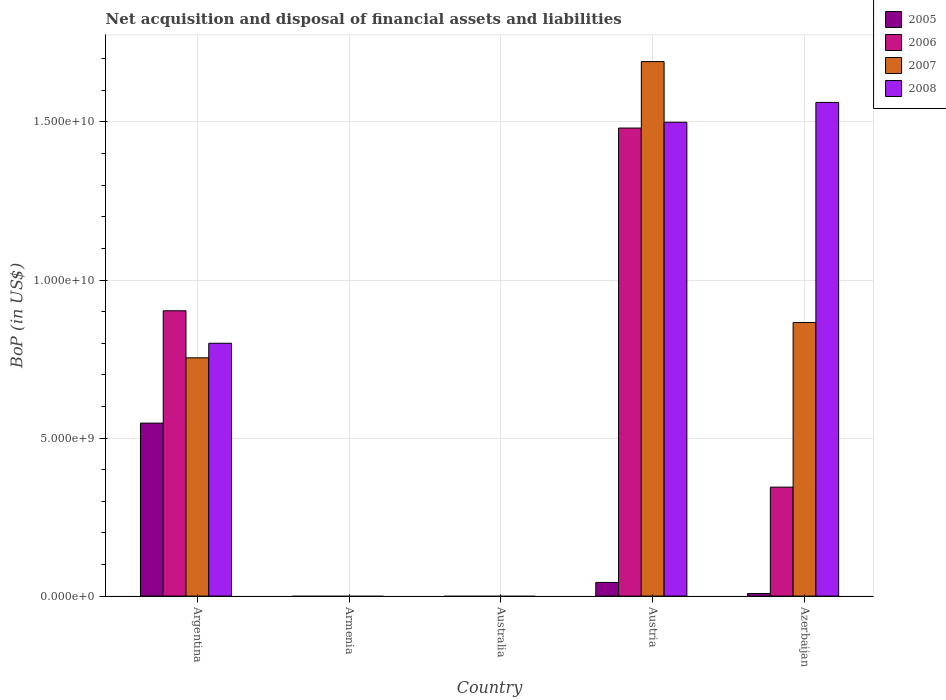How many different coloured bars are there?
Offer a very short reply. 4. How many bars are there on the 2nd tick from the right?
Your response must be concise. 4. What is the label of the 5th group of bars from the left?
Provide a succinct answer. Azerbaijan. In how many cases, is the number of bars for a given country not equal to the number of legend labels?
Provide a short and direct response. 2. What is the Balance of Payments in 2006 in Azerbaijan?
Provide a short and direct response. 3.45e+09. Across all countries, what is the maximum Balance of Payments in 2007?
Your answer should be very brief. 1.69e+1. Across all countries, what is the minimum Balance of Payments in 2007?
Provide a short and direct response. 0. In which country was the Balance of Payments in 2008 maximum?
Provide a succinct answer. Azerbaijan. What is the total Balance of Payments in 2007 in the graph?
Give a very brief answer. 3.31e+1. What is the difference between the Balance of Payments in 2007 in Argentina and that in Azerbaijan?
Provide a short and direct response. -1.12e+09. What is the difference between the Balance of Payments in 2005 in Argentina and the Balance of Payments in 2007 in Azerbaijan?
Provide a succinct answer. -3.18e+09. What is the average Balance of Payments in 2008 per country?
Offer a very short reply. 7.72e+09. What is the difference between the Balance of Payments of/in 2007 and Balance of Payments of/in 2006 in Azerbaijan?
Give a very brief answer. 5.21e+09. In how many countries, is the Balance of Payments in 2006 greater than 3000000000 US$?
Provide a succinct answer. 3. What is the ratio of the Balance of Payments in 2007 in Argentina to that in Austria?
Your response must be concise. 0.45. Is the Balance of Payments in 2006 in Argentina less than that in Austria?
Provide a succinct answer. Yes. What is the difference between the highest and the second highest Balance of Payments in 2008?
Offer a very short reply. 7.62e+09. What is the difference between the highest and the lowest Balance of Payments in 2008?
Your answer should be compact. 1.56e+1. In how many countries, is the Balance of Payments in 2006 greater than the average Balance of Payments in 2006 taken over all countries?
Your response must be concise. 2. How many countries are there in the graph?
Your answer should be compact. 5. What is the difference between two consecutive major ticks on the Y-axis?
Provide a short and direct response. 5.00e+09. Are the values on the major ticks of Y-axis written in scientific E-notation?
Provide a short and direct response. Yes. Does the graph contain any zero values?
Provide a succinct answer. Yes. Does the graph contain grids?
Keep it short and to the point. Yes. Where does the legend appear in the graph?
Offer a terse response. Top right. What is the title of the graph?
Your answer should be very brief. Net acquisition and disposal of financial assets and liabilities. Does "1983" appear as one of the legend labels in the graph?
Keep it short and to the point. No. What is the label or title of the X-axis?
Provide a succinct answer. Country. What is the label or title of the Y-axis?
Offer a terse response. BoP (in US$). What is the BoP (in US$) of 2005 in Argentina?
Ensure brevity in your answer.  5.47e+09. What is the BoP (in US$) in 2006 in Argentina?
Keep it short and to the point. 9.03e+09. What is the BoP (in US$) of 2007 in Argentina?
Your answer should be compact. 7.54e+09. What is the BoP (in US$) of 2008 in Argentina?
Your answer should be very brief. 8.00e+09. What is the BoP (in US$) in 2006 in Armenia?
Your answer should be compact. 0. What is the BoP (in US$) in 2008 in Armenia?
Your answer should be very brief. 0. What is the BoP (in US$) in 2006 in Australia?
Provide a short and direct response. 0. What is the BoP (in US$) in 2007 in Australia?
Offer a very short reply. 0. What is the BoP (in US$) of 2008 in Australia?
Provide a short and direct response. 0. What is the BoP (in US$) in 2005 in Austria?
Your answer should be very brief. 4.32e+08. What is the BoP (in US$) in 2006 in Austria?
Make the answer very short. 1.48e+1. What is the BoP (in US$) of 2007 in Austria?
Give a very brief answer. 1.69e+1. What is the BoP (in US$) in 2008 in Austria?
Offer a terse response. 1.50e+1. What is the BoP (in US$) in 2005 in Azerbaijan?
Provide a short and direct response. 8.26e+07. What is the BoP (in US$) in 2006 in Azerbaijan?
Your answer should be very brief. 3.45e+09. What is the BoP (in US$) in 2007 in Azerbaijan?
Provide a succinct answer. 8.66e+09. What is the BoP (in US$) of 2008 in Azerbaijan?
Your answer should be compact. 1.56e+1. Across all countries, what is the maximum BoP (in US$) in 2005?
Provide a succinct answer. 5.47e+09. Across all countries, what is the maximum BoP (in US$) in 2006?
Your response must be concise. 1.48e+1. Across all countries, what is the maximum BoP (in US$) of 2007?
Your response must be concise. 1.69e+1. Across all countries, what is the maximum BoP (in US$) in 2008?
Offer a terse response. 1.56e+1. Across all countries, what is the minimum BoP (in US$) in 2005?
Provide a short and direct response. 0. Across all countries, what is the minimum BoP (in US$) in 2006?
Your answer should be very brief. 0. What is the total BoP (in US$) of 2005 in the graph?
Your response must be concise. 5.99e+09. What is the total BoP (in US$) in 2006 in the graph?
Your response must be concise. 2.73e+1. What is the total BoP (in US$) of 2007 in the graph?
Your response must be concise. 3.31e+1. What is the total BoP (in US$) in 2008 in the graph?
Your answer should be very brief. 3.86e+1. What is the difference between the BoP (in US$) in 2005 in Argentina and that in Austria?
Give a very brief answer. 5.04e+09. What is the difference between the BoP (in US$) in 2006 in Argentina and that in Austria?
Your answer should be very brief. -5.78e+09. What is the difference between the BoP (in US$) in 2007 in Argentina and that in Austria?
Ensure brevity in your answer.  -9.37e+09. What is the difference between the BoP (in US$) in 2008 in Argentina and that in Austria?
Provide a short and direct response. -6.99e+09. What is the difference between the BoP (in US$) of 2005 in Argentina and that in Azerbaijan?
Keep it short and to the point. 5.39e+09. What is the difference between the BoP (in US$) in 2006 in Argentina and that in Azerbaijan?
Keep it short and to the point. 5.58e+09. What is the difference between the BoP (in US$) in 2007 in Argentina and that in Azerbaijan?
Offer a terse response. -1.12e+09. What is the difference between the BoP (in US$) in 2008 in Argentina and that in Azerbaijan?
Offer a very short reply. -7.62e+09. What is the difference between the BoP (in US$) in 2005 in Austria and that in Azerbaijan?
Offer a terse response. 3.50e+08. What is the difference between the BoP (in US$) in 2006 in Austria and that in Azerbaijan?
Offer a terse response. 1.14e+1. What is the difference between the BoP (in US$) of 2007 in Austria and that in Azerbaijan?
Offer a terse response. 8.26e+09. What is the difference between the BoP (in US$) in 2008 in Austria and that in Azerbaijan?
Provide a succinct answer. -6.27e+08. What is the difference between the BoP (in US$) of 2005 in Argentina and the BoP (in US$) of 2006 in Austria?
Provide a short and direct response. -9.33e+09. What is the difference between the BoP (in US$) of 2005 in Argentina and the BoP (in US$) of 2007 in Austria?
Make the answer very short. -1.14e+1. What is the difference between the BoP (in US$) in 2005 in Argentina and the BoP (in US$) in 2008 in Austria?
Offer a terse response. -9.52e+09. What is the difference between the BoP (in US$) in 2006 in Argentina and the BoP (in US$) in 2007 in Austria?
Your answer should be compact. -7.88e+09. What is the difference between the BoP (in US$) of 2006 in Argentina and the BoP (in US$) of 2008 in Austria?
Your answer should be very brief. -5.96e+09. What is the difference between the BoP (in US$) of 2007 in Argentina and the BoP (in US$) of 2008 in Austria?
Provide a short and direct response. -7.45e+09. What is the difference between the BoP (in US$) of 2005 in Argentina and the BoP (in US$) of 2006 in Azerbaijan?
Offer a very short reply. 2.03e+09. What is the difference between the BoP (in US$) in 2005 in Argentina and the BoP (in US$) in 2007 in Azerbaijan?
Provide a short and direct response. -3.18e+09. What is the difference between the BoP (in US$) in 2005 in Argentina and the BoP (in US$) in 2008 in Azerbaijan?
Your answer should be very brief. -1.01e+1. What is the difference between the BoP (in US$) of 2006 in Argentina and the BoP (in US$) of 2007 in Azerbaijan?
Offer a terse response. 3.72e+08. What is the difference between the BoP (in US$) in 2006 in Argentina and the BoP (in US$) in 2008 in Azerbaijan?
Your answer should be very brief. -6.59e+09. What is the difference between the BoP (in US$) in 2007 in Argentina and the BoP (in US$) in 2008 in Azerbaijan?
Your response must be concise. -8.08e+09. What is the difference between the BoP (in US$) of 2005 in Austria and the BoP (in US$) of 2006 in Azerbaijan?
Offer a terse response. -3.02e+09. What is the difference between the BoP (in US$) of 2005 in Austria and the BoP (in US$) of 2007 in Azerbaijan?
Your answer should be very brief. -8.22e+09. What is the difference between the BoP (in US$) in 2005 in Austria and the BoP (in US$) in 2008 in Azerbaijan?
Give a very brief answer. -1.52e+1. What is the difference between the BoP (in US$) in 2006 in Austria and the BoP (in US$) in 2007 in Azerbaijan?
Ensure brevity in your answer.  6.15e+09. What is the difference between the BoP (in US$) in 2006 in Austria and the BoP (in US$) in 2008 in Azerbaijan?
Provide a short and direct response. -8.11e+08. What is the difference between the BoP (in US$) in 2007 in Austria and the BoP (in US$) in 2008 in Azerbaijan?
Your answer should be compact. 1.29e+09. What is the average BoP (in US$) in 2005 per country?
Give a very brief answer. 1.20e+09. What is the average BoP (in US$) in 2006 per country?
Make the answer very short. 5.46e+09. What is the average BoP (in US$) of 2007 per country?
Make the answer very short. 6.62e+09. What is the average BoP (in US$) of 2008 per country?
Ensure brevity in your answer.  7.72e+09. What is the difference between the BoP (in US$) in 2005 and BoP (in US$) in 2006 in Argentina?
Your answer should be compact. -3.55e+09. What is the difference between the BoP (in US$) of 2005 and BoP (in US$) of 2007 in Argentina?
Offer a terse response. -2.07e+09. What is the difference between the BoP (in US$) in 2005 and BoP (in US$) in 2008 in Argentina?
Your answer should be compact. -2.53e+09. What is the difference between the BoP (in US$) of 2006 and BoP (in US$) of 2007 in Argentina?
Your answer should be compact. 1.49e+09. What is the difference between the BoP (in US$) of 2006 and BoP (in US$) of 2008 in Argentina?
Make the answer very short. 1.03e+09. What is the difference between the BoP (in US$) in 2007 and BoP (in US$) in 2008 in Argentina?
Keep it short and to the point. -4.61e+08. What is the difference between the BoP (in US$) in 2005 and BoP (in US$) in 2006 in Austria?
Offer a terse response. -1.44e+1. What is the difference between the BoP (in US$) of 2005 and BoP (in US$) of 2007 in Austria?
Give a very brief answer. -1.65e+1. What is the difference between the BoP (in US$) of 2005 and BoP (in US$) of 2008 in Austria?
Your answer should be compact. -1.46e+1. What is the difference between the BoP (in US$) of 2006 and BoP (in US$) of 2007 in Austria?
Make the answer very short. -2.10e+09. What is the difference between the BoP (in US$) of 2006 and BoP (in US$) of 2008 in Austria?
Your answer should be compact. -1.83e+08. What is the difference between the BoP (in US$) in 2007 and BoP (in US$) in 2008 in Austria?
Give a very brief answer. 1.92e+09. What is the difference between the BoP (in US$) of 2005 and BoP (in US$) of 2006 in Azerbaijan?
Provide a succinct answer. -3.37e+09. What is the difference between the BoP (in US$) in 2005 and BoP (in US$) in 2007 in Azerbaijan?
Offer a terse response. -8.57e+09. What is the difference between the BoP (in US$) of 2005 and BoP (in US$) of 2008 in Azerbaijan?
Offer a very short reply. -1.55e+1. What is the difference between the BoP (in US$) of 2006 and BoP (in US$) of 2007 in Azerbaijan?
Your response must be concise. -5.21e+09. What is the difference between the BoP (in US$) in 2006 and BoP (in US$) in 2008 in Azerbaijan?
Give a very brief answer. -1.22e+1. What is the difference between the BoP (in US$) of 2007 and BoP (in US$) of 2008 in Azerbaijan?
Provide a short and direct response. -6.96e+09. What is the ratio of the BoP (in US$) of 2005 in Argentina to that in Austria?
Make the answer very short. 12.66. What is the ratio of the BoP (in US$) in 2006 in Argentina to that in Austria?
Keep it short and to the point. 0.61. What is the ratio of the BoP (in US$) in 2007 in Argentina to that in Austria?
Your response must be concise. 0.45. What is the ratio of the BoP (in US$) of 2008 in Argentina to that in Austria?
Your answer should be very brief. 0.53. What is the ratio of the BoP (in US$) in 2005 in Argentina to that in Azerbaijan?
Give a very brief answer. 66.23. What is the ratio of the BoP (in US$) of 2006 in Argentina to that in Azerbaijan?
Your answer should be very brief. 2.62. What is the ratio of the BoP (in US$) in 2007 in Argentina to that in Azerbaijan?
Your answer should be compact. 0.87. What is the ratio of the BoP (in US$) of 2008 in Argentina to that in Azerbaijan?
Your response must be concise. 0.51. What is the ratio of the BoP (in US$) of 2005 in Austria to that in Azerbaijan?
Offer a very short reply. 5.23. What is the ratio of the BoP (in US$) of 2006 in Austria to that in Azerbaijan?
Offer a terse response. 4.29. What is the ratio of the BoP (in US$) of 2007 in Austria to that in Azerbaijan?
Offer a terse response. 1.95. What is the ratio of the BoP (in US$) in 2008 in Austria to that in Azerbaijan?
Provide a succinct answer. 0.96. What is the difference between the highest and the second highest BoP (in US$) in 2005?
Your answer should be compact. 5.04e+09. What is the difference between the highest and the second highest BoP (in US$) in 2006?
Provide a succinct answer. 5.78e+09. What is the difference between the highest and the second highest BoP (in US$) in 2007?
Offer a terse response. 8.26e+09. What is the difference between the highest and the second highest BoP (in US$) of 2008?
Make the answer very short. 6.27e+08. What is the difference between the highest and the lowest BoP (in US$) in 2005?
Your response must be concise. 5.47e+09. What is the difference between the highest and the lowest BoP (in US$) in 2006?
Offer a terse response. 1.48e+1. What is the difference between the highest and the lowest BoP (in US$) in 2007?
Give a very brief answer. 1.69e+1. What is the difference between the highest and the lowest BoP (in US$) of 2008?
Provide a short and direct response. 1.56e+1. 